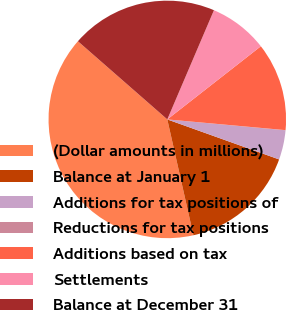<chart> <loc_0><loc_0><loc_500><loc_500><pie_chart><fcel>(Dollar amounts in millions)<fcel>Balance at January 1<fcel>Additions for tax positions of<fcel>Reductions for tax positions<fcel>Additions based on tax<fcel>Settlements<fcel>Balance at December 31<nl><fcel>39.96%<fcel>16.0%<fcel>4.01%<fcel>0.02%<fcel>12.0%<fcel>8.01%<fcel>19.99%<nl></chart> 